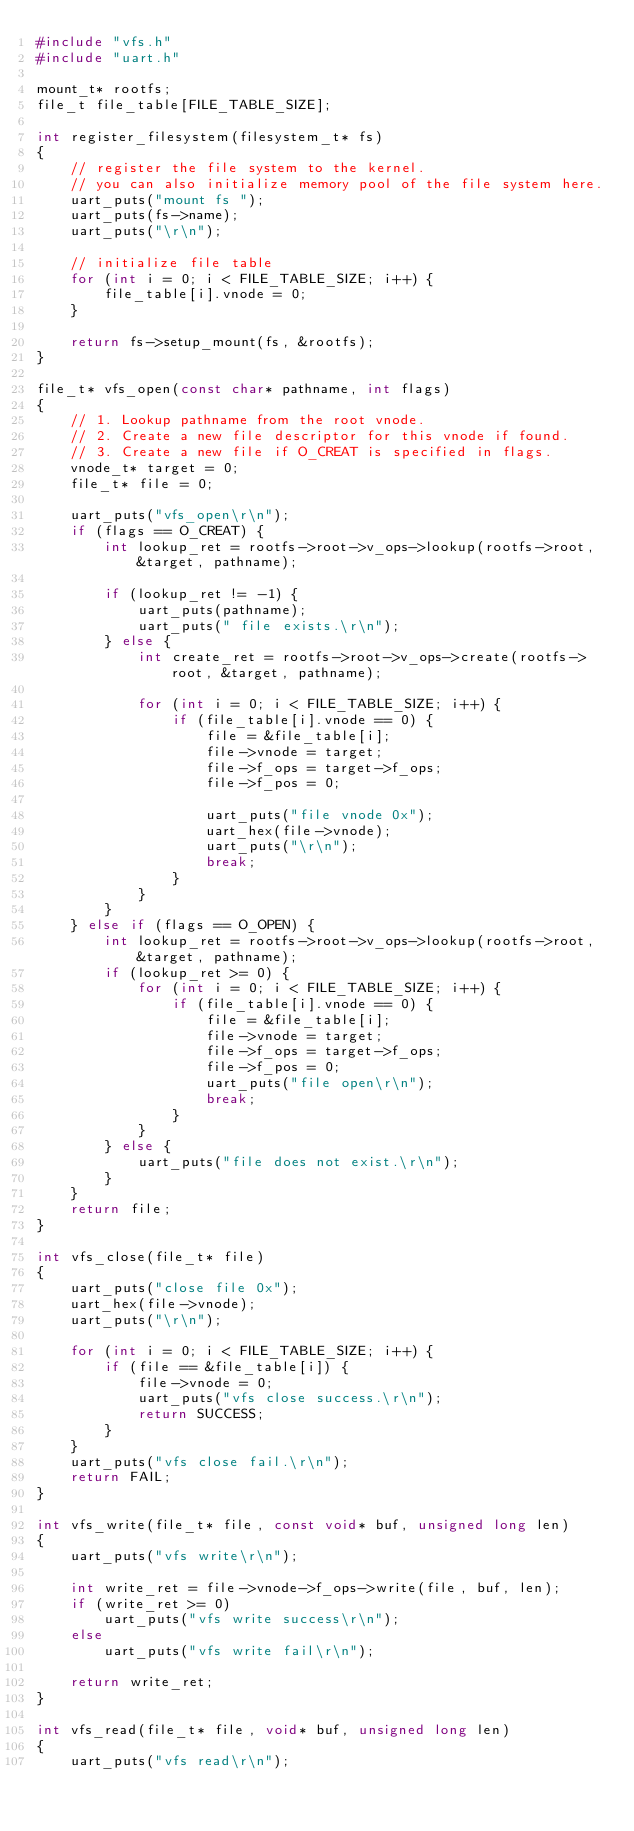Convert code to text. <code><loc_0><loc_0><loc_500><loc_500><_C_>#include "vfs.h"
#include "uart.h"

mount_t* rootfs;
file_t file_table[FILE_TABLE_SIZE];

int register_filesystem(filesystem_t* fs)
{
    // register the file system to the kernel.
    // you can also initialize memory pool of the file system here.
    uart_puts("mount fs ");
    uart_puts(fs->name);
    uart_puts("\r\n");

    // initialize file table
    for (int i = 0; i < FILE_TABLE_SIZE; i++) {
        file_table[i].vnode = 0;
    }

    return fs->setup_mount(fs, &rootfs);
}

file_t* vfs_open(const char* pathname, int flags)
{
    // 1. Lookup pathname from the root vnode.
    // 2. Create a new file descriptor for this vnode if found.
    // 3. Create a new file if O_CREAT is specified in flags.
    vnode_t* target = 0;
    file_t* file = 0;

    uart_puts("vfs_open\r\n");
    if (flags == O_CREAT) {
        int lookup_ret = rootfs->root->v_ops->lookup(rootfs->root, &target, pathname);

        if (lookup_ret != -1) {
            uart_puts(pathname);
            uart_puts(" file exists.\r\n");
        } else {
            int create_ret = rootfs->root->v_ops->create(rootfs->root, &target, pathname);

            for (int i = 0; i < FILE_TABLE_SIZE; i++) {
                if (file_table[i].vnode == 0) {
                    file = &file_table[i];
                    file->vnode = target;
                    file->f_ops = target->f_ops;
                    file->f_pos = 0;

                    uart_puts("file vnode 0x");
                    uart_hex(file->vnode);
                    uart_puts("\r\n");
                    break;
                }
            }
        }
    } else if (flags == O_OPEN) {
        int lookup_ret = rootfs->root->v_ops->lookup(rootfs->root, &target, pathname);
        if (lookup_ret >= 0) {
            for (int i = 0; i < FILE_TABLE_SIZE; i++) {
                if (file_table[i].vnode == 0) {
                    file = &file_table[i];
                    file->vnode = target;
                    file->f_ops = target->f_ops;
                    file->f_pos = 0;
                    uart_puts("file open\r\n");
                    break;
                }
            }
        } else {
            uart_puts("file does not exist.\r\n");
        }
    }
    return file;
}

int vfs_close(file_t* file)
{
    uart_puts("close file 0x");
    uart_hex(file->vnode);
    uart_puts("\r\n");

    for (int i = 0; i < FILE_TABLE_SIZE; i++) {
        if (file == &file_table[i]) {
            file->vnode = 0;
            uart_puts("vfs close success.\r\n");
            return SUCCESS;
        }
    }
    uart_puts("vfs close fail.\r\n");
    return FAIL;
}

int vfs_write(file_t* file, const void* buf, unsigned long len)
{
    uart_puts("vfs write\r\n");

    int write_ret = file->vnode->f_ops->write(file, buf, len);
    if (write_ret >= 0)
        uart_puts("vfs write success\r\n");
    else
        uart_puts("vfs write fail\r\n");

    return write_ret;
}

int vfs_read(file_t* file, void* buf, unsigned long len)
{
    uart_puts("vfs read\r\n");
</code> 